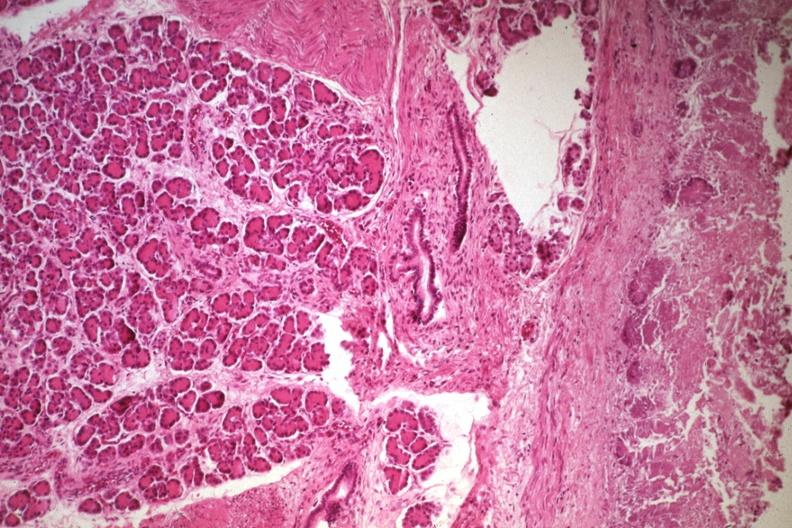s jejunum present?
Answer the question using a single word or phrase. Yes 